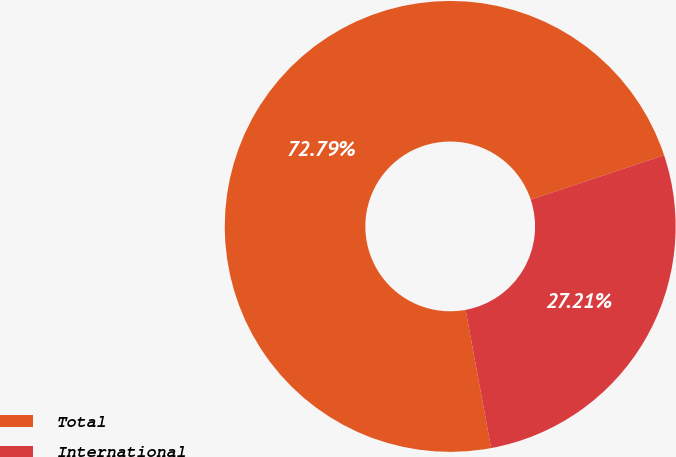<chart> <loc_0><loc_0><loc_500><loc_500><pie_chart><fcel>Total<fcel>International<nl><fcel>72.79%<fcel>27.21%<nl></chart> 